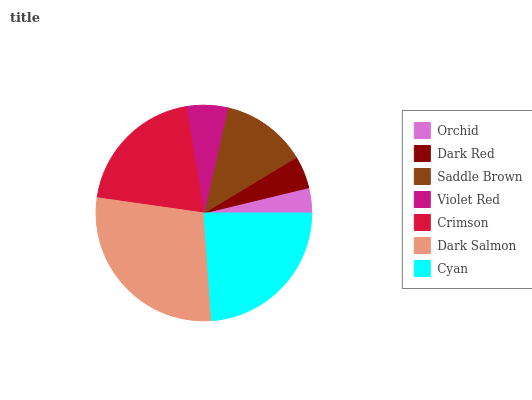Is Orchid the minimum?
Answer yes or no. Yes. Is Dark Salmon the maximum?
Answer yes or no. Yes. Is Dark Red the minimum?
Answer yes or no. No. Is Dark Red the maximum?
Answer yes or no. No. Is Dark Red greater than Orchid?
Answer yes or no. Yes. Is Orchid less than Dark Red?
Answer yes or no. Yes. Is Orchid greater than Dark Red?
Answer yes or no. No. Is Dark Red less than Orchid?
Answer yes or no. No. Is Saddle Brown the high median?
Answer yes or no. Yes. Is Saddle Brown the low median?
Answer yes or no. Yes. Is Cyan the high median?
Answer yes or no. No. Is Crimson the low median?
Answer yes or no. No. 